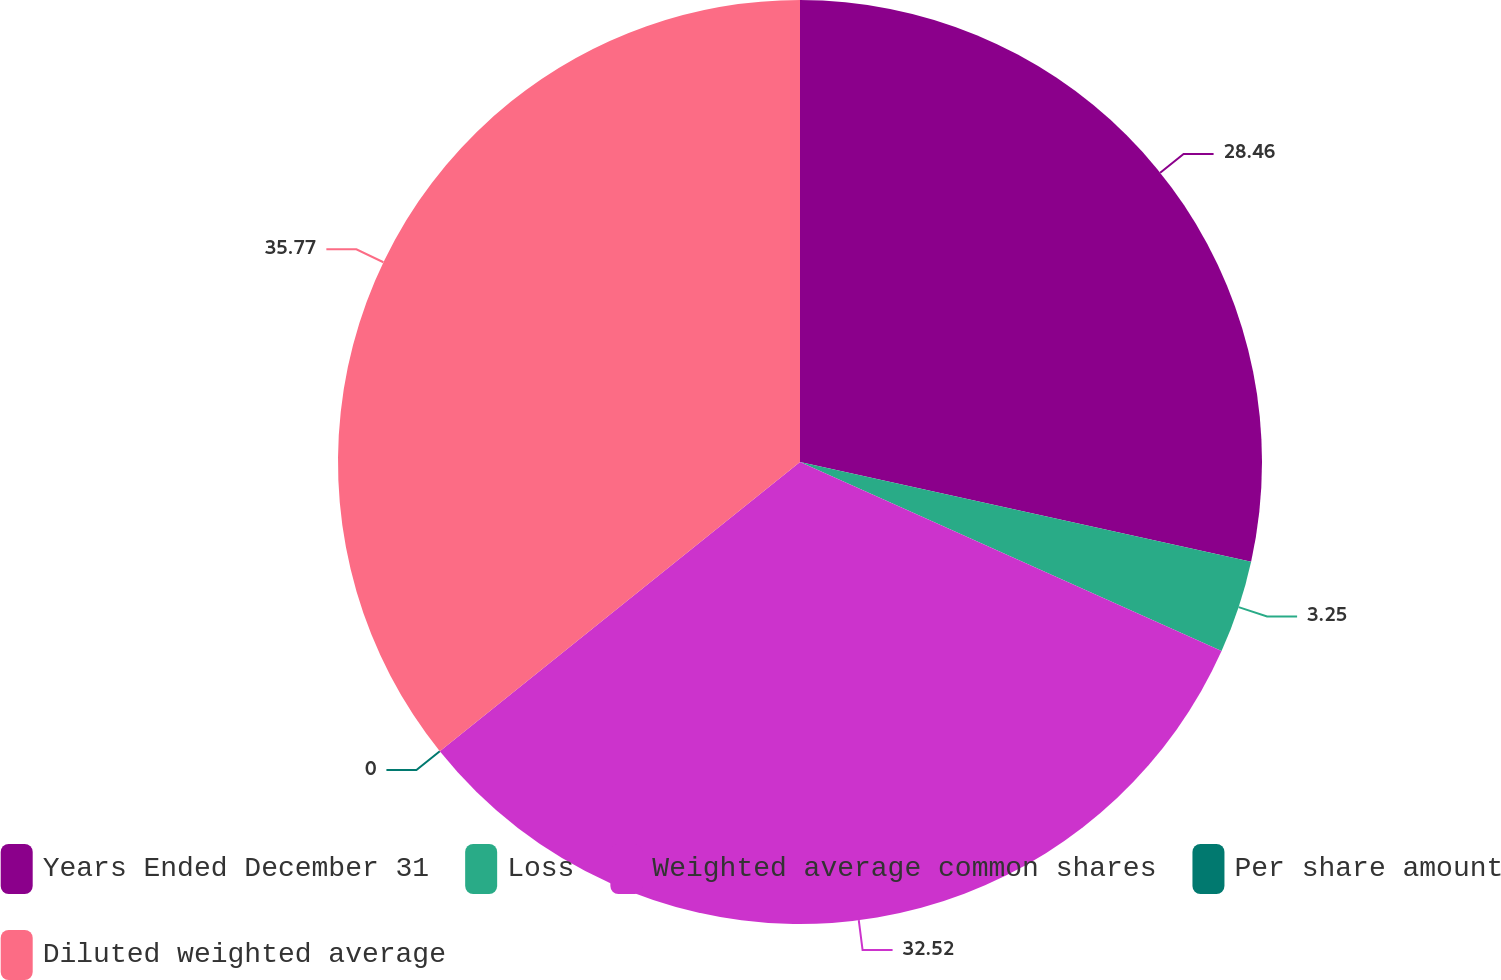Convert chart to OTSL. <chart><loc_0><loc_0><loc_500><loc_500><pie_chart><fcel>Years Ended December 31<fcel>Loss<fcel>Weighted average common shares<fcel>Per share amount<fcel>Diluted weighted average<nl><fcel>28.46%<fcel>3.25%<fcel>32.52%<fcel>0.0%<fcel>35.77%<nl></chart> 